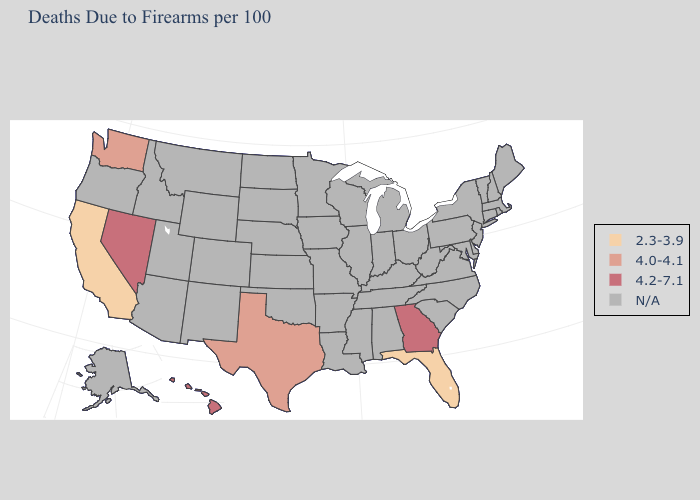Is the legend a continuous bar?
Write a very short answer. No. Name the states that have a value in the range N/A?
Quick response, please. Alabama, Alaska, Arizona, Arkansas, Colorado, Connecticut, Delaware, Idaho, Illinois, Indiana, Iowa, Kansas, Kentucky, Louisiana, Maine, Maryland, Massachusetts, Michigan, Minnesota, Mississippi, Missouri, Montana, Nebraska, New Hampshire, New Jersey, New Mexico, New York, North Carolina, North Dakota, Ohio, Oklahoma, Oregon, Pennsylvania, Rhode Island, South Carolina, South Dakota, Tennessee, Utah, Vermont, Virginia, West Virginia, Wisconsin, Wyoming. What is the value of Illinois?
Short answer required. N/A. Name the states that have a value in the range N/A?
Keep it brief. Alabama, Alaska, Arizona, Arkansas, Colorado, Connecticut, Delaware, Idaho, Illinois, Indiana, Iowa, Kansas, Kentucky, Louisiana, Maine, Maryland, Massachusetts, Michigan, Minnesota, Mississippi, Missouri, Montana, Nebraska, New Hampshire, New Jersey, New Mexico, New York, North Carolina, North Dakota, Ohio, Oklahoma, Oregon, Pennsylvania, Rhode Island, South Carolina, South Dakota, Tennessee, Utah, Vermont, Virginia, West Virginia, Wisconsin, Wyoming. Name the states that have a value in the range 4.0-4.1?
Short answer required. Texas, Washington. Name the states that have a value in the range N/A?
Keep it brief. Alabama, Alaska, Arizona, Arkansas, Colorado, Connecticut, Delaware, Idaho, Illinois, Indiana, Iowa, Kansas, Kentucky, Louisiana, Maine, Maryland, Massachusetts, Michigan, Minnesota, Mississippi, Missouri, Montana, Nebraska, New Hampshire, New Jersey, New Mexico, New York, North Carolina, North Dakota, Ohio, Oklahoma, Oregon, Pennsylvania, Rhode Island, South Carolina, South Dakota, Tennessee, Utah, Vermont, Virginia, West Virginia, Wisconsin, Wyoming. Name the states that have a value in the range 4.2-7.1?
Quick response, please. Georgia, Hawaii, Nevada. Name the states that have a value in the range N/A?
Be succinct. Alabama, Alaska, Arizona, Arkansas, Colorado, Connecticut, Delaware, Idaho, Illinois, Indiana, Iowa, Kansas, Kentucky, Louisiana, Maine, Maryland, Massachusetts, Michigan, Minnesota, Mississippi, Missouri, Montana, Nebraska, New Hampshire, New Jersey, New Mexico, New York, North Carolina, North Dakota, Ohio, Oklahoma, Oregon, Pennsylvania, Rhode Island, South Carolina, South Dakota, Tennessee, Utah, Vermont, Virginia, West Virginia, Wisconsin, Wyoming. What is the value of Michigan?
Concise answer only. N/A. 